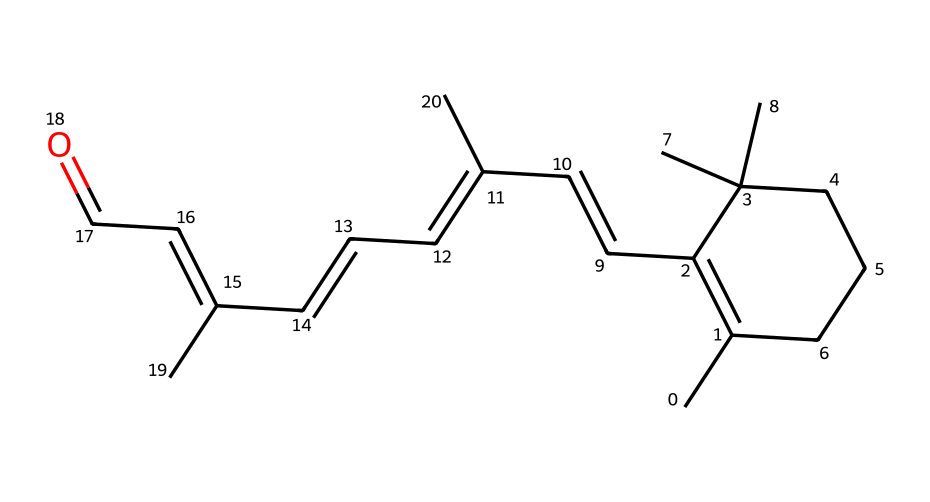What is the molecular formula of this compound? To determine the molecular formula, count the number of each type of atom present in the SMILES representation. The compound has 20 carbon atoms, 30 hydrogen atoms, and 1 oxygen atom, giving the molecular formula C20H30O.
Answer: C20H30O How many double bonds are in this molecule? Analyze the SMILES representation for double bond symbols (=) between atoms. The representation shows 4 instances of double bonds, indicating that there are 4 double bonds in the molecule.
Answer: 4 What is the name of this compound? The compound is known as retinol, a vitamin A derivative commonly used in skincare products. Identifying the compound can be done through existing chemical knowledge associated with the provided SMILES.
Answer: retinol How many geometric isomers can this compound form? The presence of multiple double bonds in the compound leads to the formation of geometric isomers due to the possibility of cis/trans configurations around the double bonds. Given 4 double bonds, the molecule can theoretically have a range of geometric isomers. This requires applying combinatorial reasoning, typically resulting in several isomers. For retinol, there are 2 main geometric isomers.
Answer: 2 Which part of the molecule contributes to its geometric isomerism? Geometric isomerism arises from the presence of double bonds, which restrict rotation. In this compound, the double bonds between the carbon atoms (specifically around the alkenes) are the parts that contribute to the potential for geometric isomers (cis/trans forms).
Answer: double bonds In which geometric configuration is retinol primarily found? The primary geometric configuration of retinol is the trans form, which is preferred due to steric factors in the molecule. This information is based on structural properties of retinol identified in chemical literature.
Answer: trans What is the functional group present in this molecule? The molecule contains an aldehyde functional group, characterized by the -CHO group found at the end of the carbon chain. Identifying functional groups requires recognizing specific arrangements of atoms that define them in organic chemistry.
Answer: aldehyde 